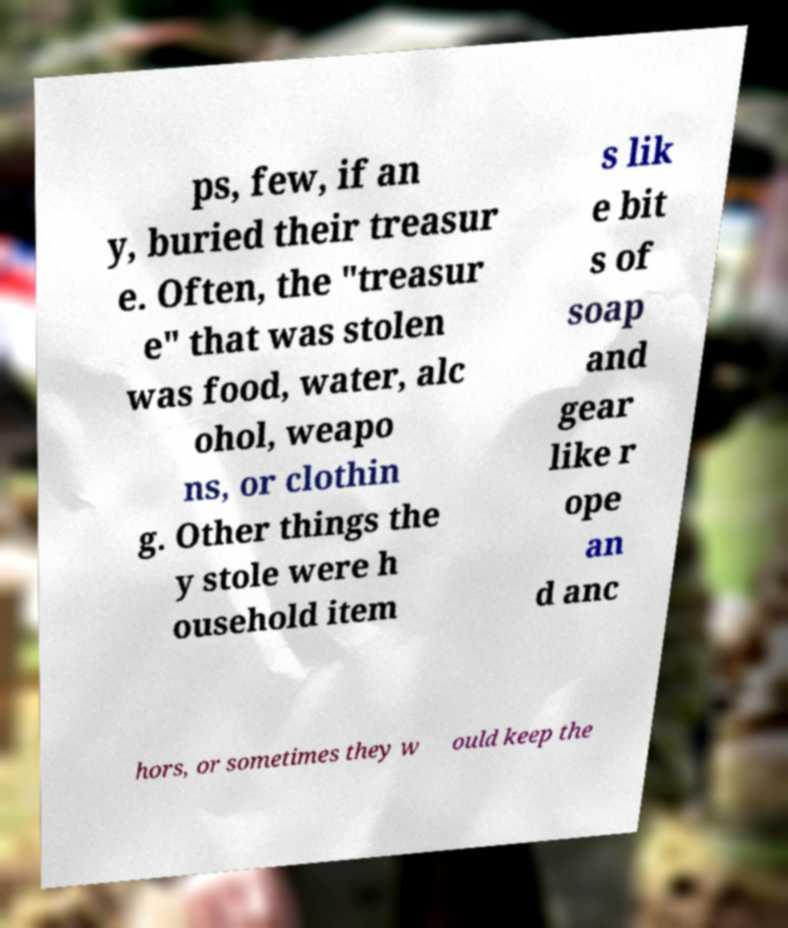Can you read and provide the text displayed in the image?This photo seems to have some interesting text. Can you extract and type it out for me? ps, few, if an y, buried their treasur e. Often, the "treasur e" that was stolen was food, water, alc ohol, weapo ns, or clothin g. Other things the y stole were h ousehold item s lik e bit s of soap and gear like r ope an d anc hors, or sometimes they w ould keep the 